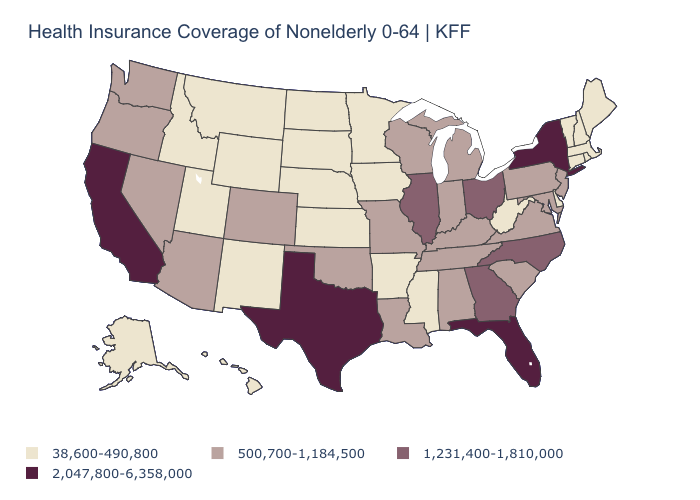What is the value of Tennessee?
Give a very brief answer. 500,700-1,184,500. Is the legend a continuous bar?
Write a very short answer. No. Which states have the highest value in the USA?
Give a very brief answer. California, Florida, New York, Texas. Among the states that border Illinois , does Iowa have the lowest value?
Write a very short answer. Yes. Name the states that have a value in the range 1,231,400-1,810,000?
Be succinct. Georgia, Illinois, North Carolina, Ohio. Does Wyoming have the highest value in the USA?
Quick response, please. No. Among the states that border New York , which have the highest value?
Give a very brief answer. New Jersey, Pennsylvania. Name the states that have a value in the range 500,700-1,184,500?
Write a very short answer. Alabama, Arizona, Colorado, Indiana, Kentucky, Louisiana, Maryland, Michigan, Missouri, Nevada, New Jersey, Oklahoma, Oregon, Pennsylvania, South Carolina, Tennessee, Virginia, Washington, Wisconsin. Among the states that border Maine , which have the highest value?
Quick response, please. New Hampshire. What is the highest value in the West ?
Write a very short answer. 2,047,800-6,358,000. What is the highest value in states that border Tennessee?
Quick response, please. 1,231,400-1,810,000. Which states have the lowest value in the Northeast?
Be succinct. Connecticut, Maine, Massachusetts, New Hampshire, Rhode Island, Vermont. What is the value of Vermont?
Be succinct. 38,600-490,800. Name the states that have a value in the range 38,600-490,800?
Concise answer only. Alaska, Arkansas, Connecticut, Delaware, Hawaii, Idaho, Iowa, Kansas, Maine, Massachusetts, Minnesota, Mississippi, Montana, Nebraska, New Hampshire, New Mexico, North Dakota, Rhode Island, South Dakota, Utah, Vermont, West Virginia, Wyoming. What is the value of Idaho?
Give a very brief answer. 38,600-490,800. 